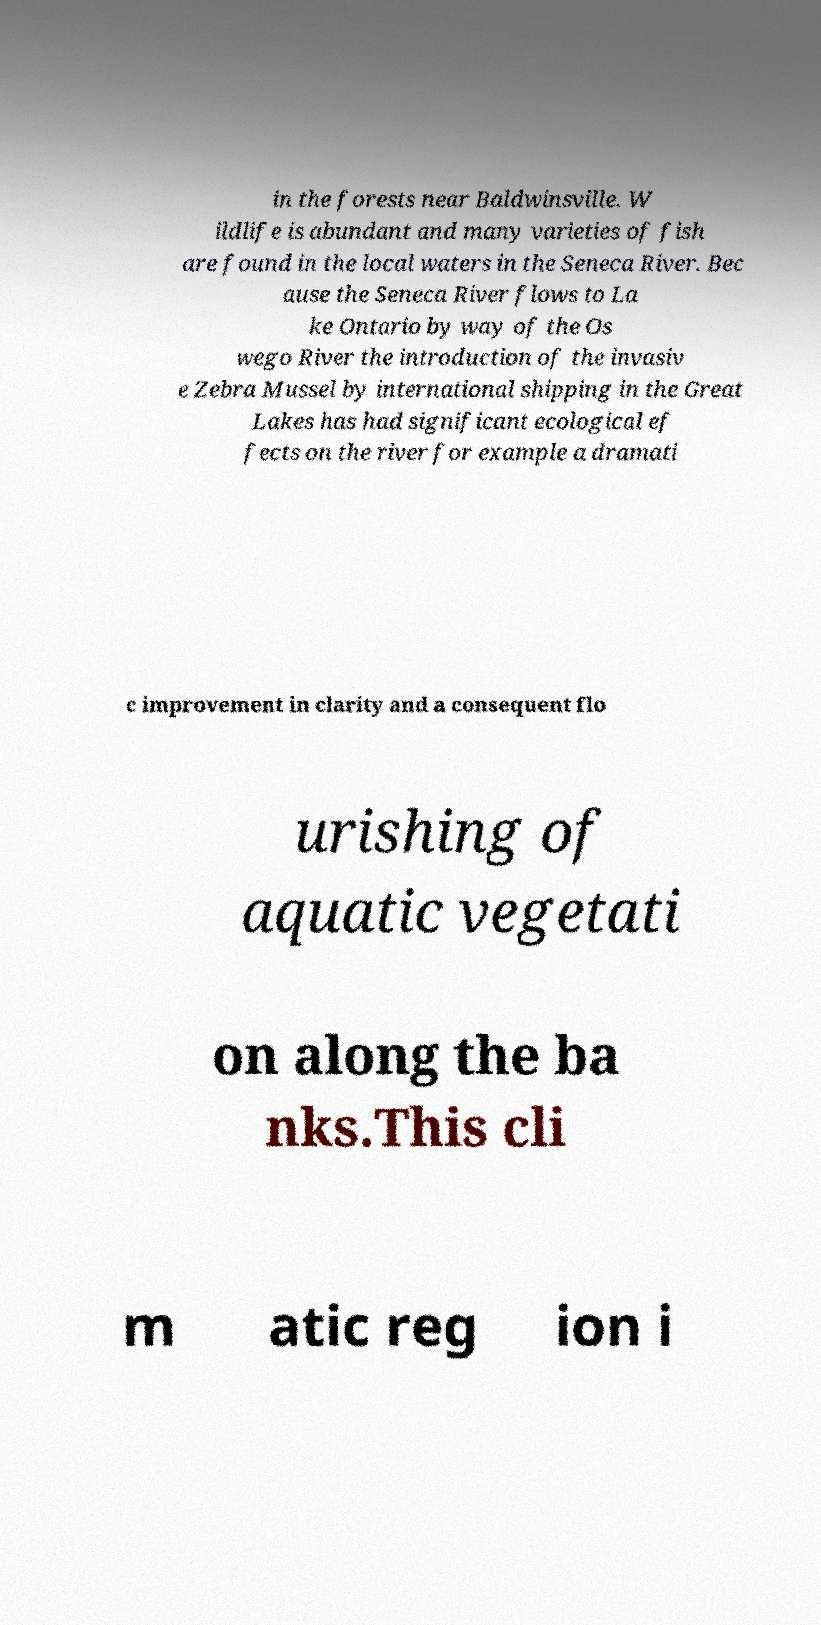Can you accurately transcribe the text from the provided image for me? in the forests near Baldwinsville. W ildlife is abundant and many varieties of fish are found in the local waters in the Seneca River. Bec ause the Seneca River flows to La ke Ontario by way of the Os wego River the introduction of the invasiv e Zebra Mussel by international shipping in the Great Lakes has had significant ecological ef fects on the river for example a dramati c improvement in clarity and a consequent flo urishing of aquatic vegetati on along the ba nks.This cli m atic reg ion i 